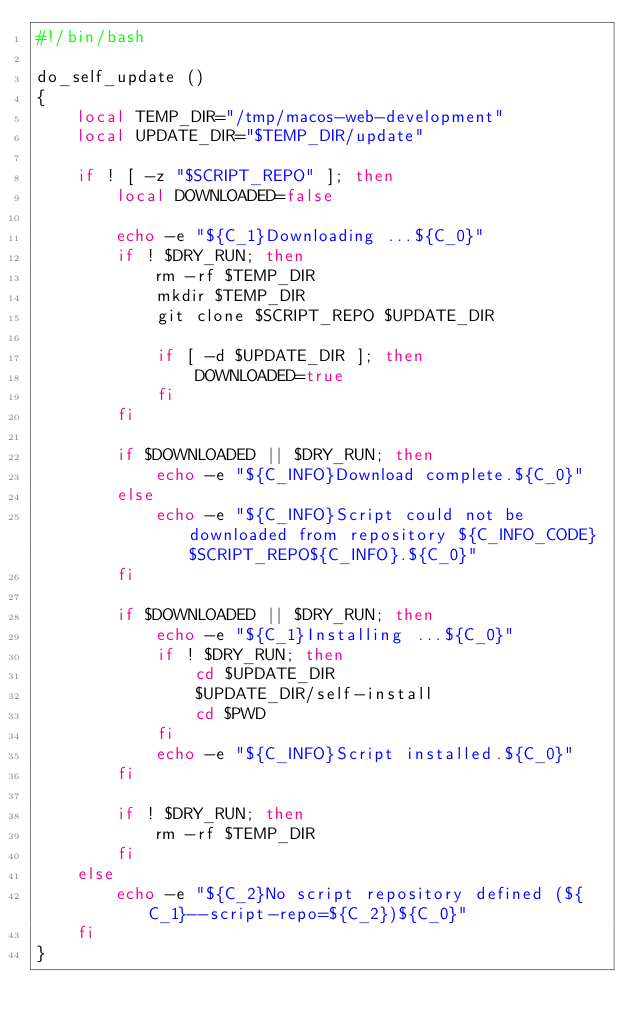Convert code to text. <code><loc_0><loc_0><loc_500><loc_500><_Bash_>#!/bin/bash

do_self_update ()
{
    local TEMP_DIR="/tmp/macos-web-development"
    local UPDATE_DIR="$TEMP_DIR/update"

    if ! [ -z "$SCRIPT_REPO" ]; then
        local DOWNLOADED=false

        echo -e "${C_1}Downloading ...${C_0}"
        if ! $DRY_RUN; then
            rm -rf $TEMP_DIR
            mkdir $TEMP_DIR
            git clone $SCRIPT_REPO $UPDATE_DIR

            if [ -d $UPDATE_DIR ]; then
                DOWNLOADED=true
            fi
        fi

        if $DOWNLOADED || $DRY_RUN; then
            echo -e "${C_INFO}Download complete.${C_0}"    
        else
            echo -e "${C_INFO}Script could not be downloaded from repository ${C_INFO_CODE}$SCRIPT_REPO${C_INFO}.${C_0}"    
        fi

        if $DOWNLOADED || $DRY_RUN; then
            echo -e "${C_1}Installing ...${C_0}"
            if ! $DRY_RUN; then
                cd $UPDATE_DIR
                $UPDATE_DIR/self-install
                cd $PWD
            fi
            echo -e "${C_INFO}Script installed.${C_0}"
        fi

        if ! $DRY_RUN; then
            rm -rf $TEMP_DIR
        fi
    else
        echo -e "${C_2}No script repository defined (${C_1}--script-repo=${C_2})${C_0}"
    fi
}
</code> 